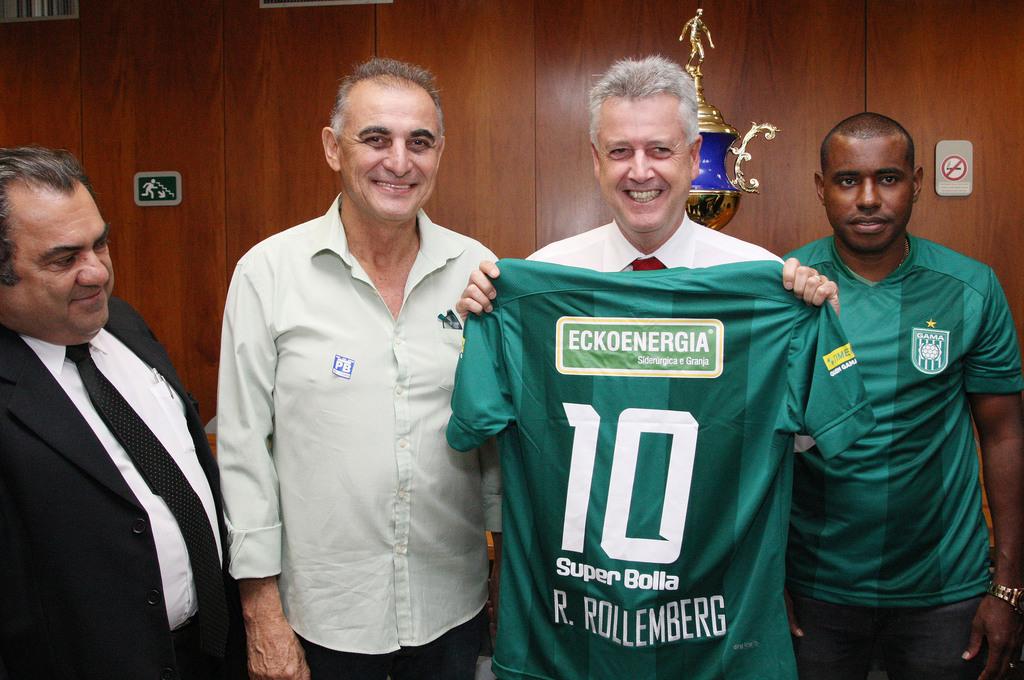What is this jersey number?
Make the answer very short. 10. Who is the teams sponsor?
Provide a succinct answer. Eckoenergia. 